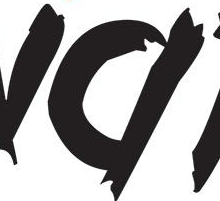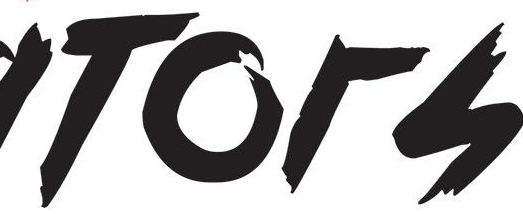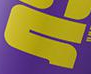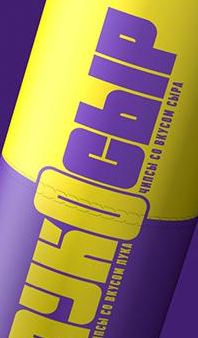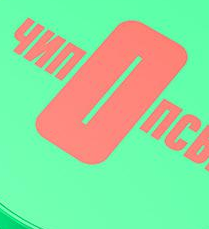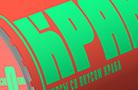What text is displayed in these images sequentially, separated by a semicolon? #; TOrS; #; YKOCbIP; nOnC; KPA 